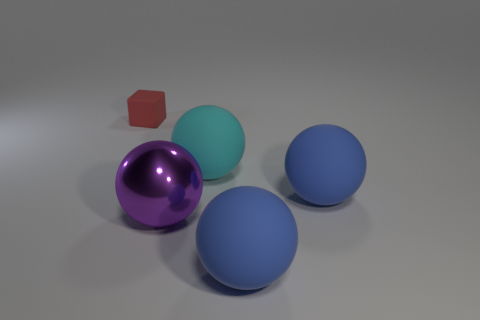Add 3 purple metal spheres. How many objects exist? 8 Subtract all spheres. How many objects are left? 1 Add 1 tiny red things. How many tiny red things are left? 2 Add 1 tiny red cubes. How many tiny red cubes exist? 2 Subtract 0 purple blocks. How many objects are left? 5 Subtract all shiny things. Subtract all large blue balls. How many objects are left? 2 